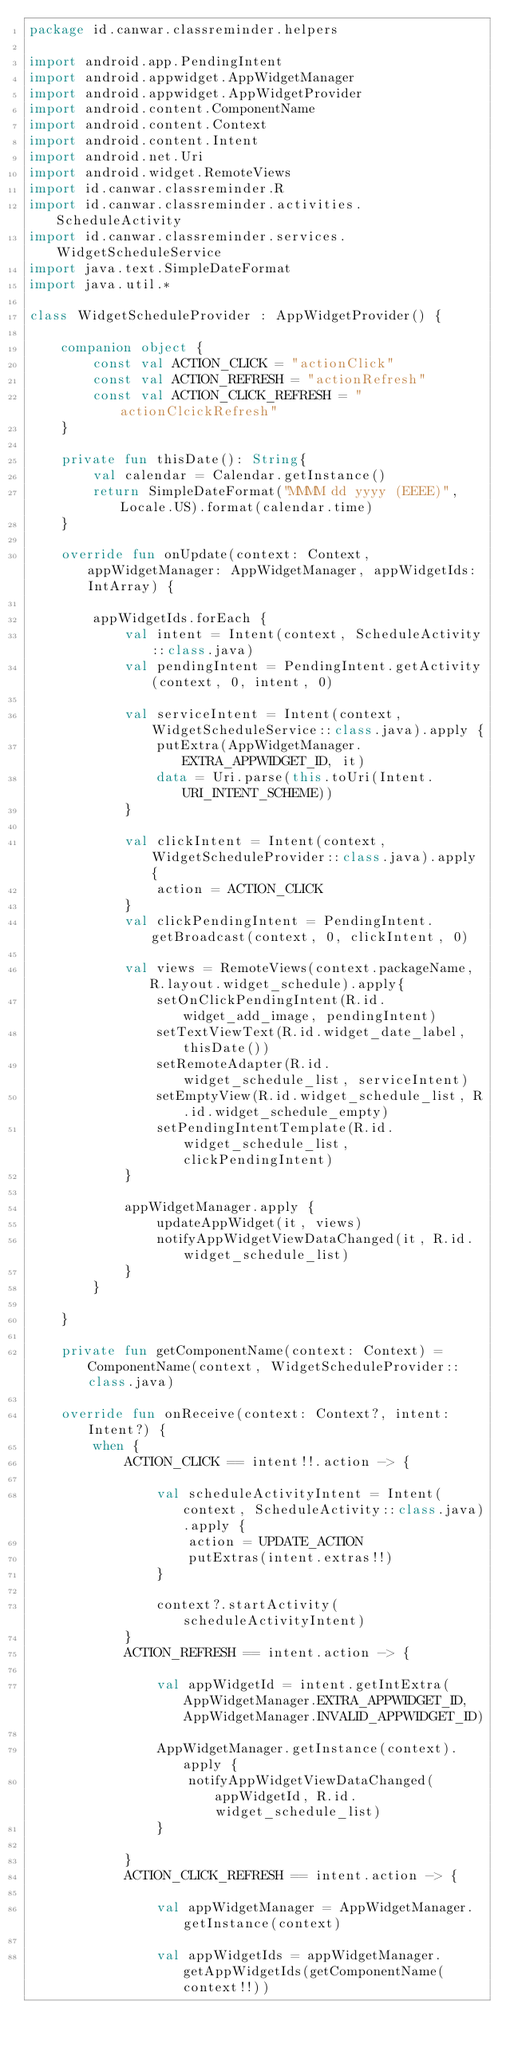<code> <loc_0><loc_0><loc_500><loc_500><_Kotlin_>package id.canwar.classreminder.helpers

import android.app.PendingIntent
import android.appwidget.AppWidgetManager
import android.appwidget.AppWidgetProvider
import android.content.ComponentName
import android.content.Context
import android.content.Intent
import android.net.Uri
import android.widget.RemoteViews
import id.canwar.classreminder.R
import id.canwar.classreminder.activities.ScheduleActivity
import id.canwar.classreminder.services.WidgetScheduleService
import java.text.SimpleDateFormat
import java.util.*

class WidgetScheduleProvider : AppWidgetProvider() {

    companion object {
        const val ACTION_CLICK = "actionClick"
        const val ACTION_REFRESH = "actionRefresh"
        const val ACTION_CLICK_REFRESH = "actionClcickRefresh"
    }

    private fun thisDate(): String{
        val calendar = Calendar.getInstance()
        return SimpleDateFormat("MMMM dd yyyy (EEEE)", Locale.US).format(calendar.time)
    }

    override fun onUpdate(context: Context, appWidgetManager: AppWidgetManager, appWidgetIds: IntArray) {

        appWidgetIds.forEach {
            val intent = Intent(context, ScheduleActivity::class.java)
            val pendingIntent = PendingIntent.getActivity(context, 0, intent, 0)

            val serviceIntent = Intent(context, WidgetScheduleService::class.java).apply {
                putExtra(AppWidgetManager.EXTRA_APPWIDGET_ID, it)
                data = Uri.parse(this.toUri(Intent.URI_INTENT_SCHEME))
            }

            val clickIntent = Intent(context, WidgetScheduleProvider::class.java).apply {
                action = ACTION_CLICK
            }
            val clickPendingIntent = PendingIntent.getBroadcast(context, 0, clickIntent, 0)

            val views = RemoteViews(context.packageName, R.layout.widget_schedule).apply{
                setOnClickPendingIntent(R.id.widget_add_image, pendingIntent)
                setTextViewText(R.id.widget_date_label, thisDate())
                setRemoteAdapter(R.id.widget_schedule_list, serviceIntent)
                setEmptyView(R.id.widget_schedule_list, R.id.widget_schedule_empty)
                setPendingIntentTemplate(R.id.widget_schedule_list, clickPendingIntent)
            }

            appWidgetManager.apply {
                updateAppWidget(it, views)
                notifyAppWidgetViewDataChanged(it, R.id.widget_schedule_list)
            }
        }

    }

    private fun getComponentName(context: Context) = ComponentName(context, WidgetScheduleProvider::class.java)

    override fun onReceive(context: Context?, intent: Intent?) {
        when {
            ACTION_CLICK == intent!!.action -> {

                val scheduleActivityIntent = Intent(context, ScheduleActivity::class.java).apply {
                    action = UPDATE_ACTION
                    putExtras(intent.extras!!)
                }

                context?.startActivity(scheduleActivityIntent)
            }
            ACTION_REFRESH == intent.action -> {

                val appWidgetId = intent.getIntExtra(AppWidgetManager.EXTRA_APPWIDGET_ID, AppWidgetManager.INVALID_APPWIDGET_ID)

                AppWidgetManager.getInstance(context).apply {
                    notifyAppWidgetViewDataChanged(appWidgetId, R.id.widget_schedule_list)
                }

            }
            ACTION_CLICK_REFRESH == intent.action -> {

                val appWidgetManager = AppWidgetManager.getInstance(context)

                val appWidgetIds = appWidgetManager.getAppWidgetIds(getComponentName(context!!))</code> 